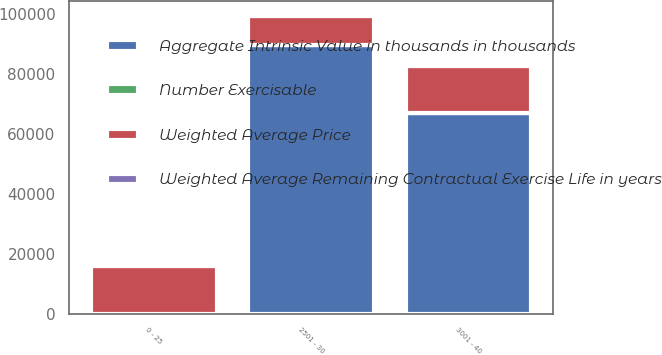Convert chart to OTSL. <chart><loc_0><loc_0><loc_500><loc_500><stacked_bar_chart><ecel><fcel>0 - 25<fcel>2501 - 30<fcel>3001 - 40<nl><fcel>Weighted Average Price<fcel>15949<fcel>9520<fcel>15737<nl><fcel>Number Exercisable<fcel>5.6<fcel>5<fcel>6.8<nl><fcel>Weighted Average Remaining Contractual Exercise Life in years<fcel>20<fcel>27<fcel>33<nl><fcel>Aggregate Intrinsic Value in thousands in thousands<fcel>33<fcel>89711<fcel>67079<nl></chart> 